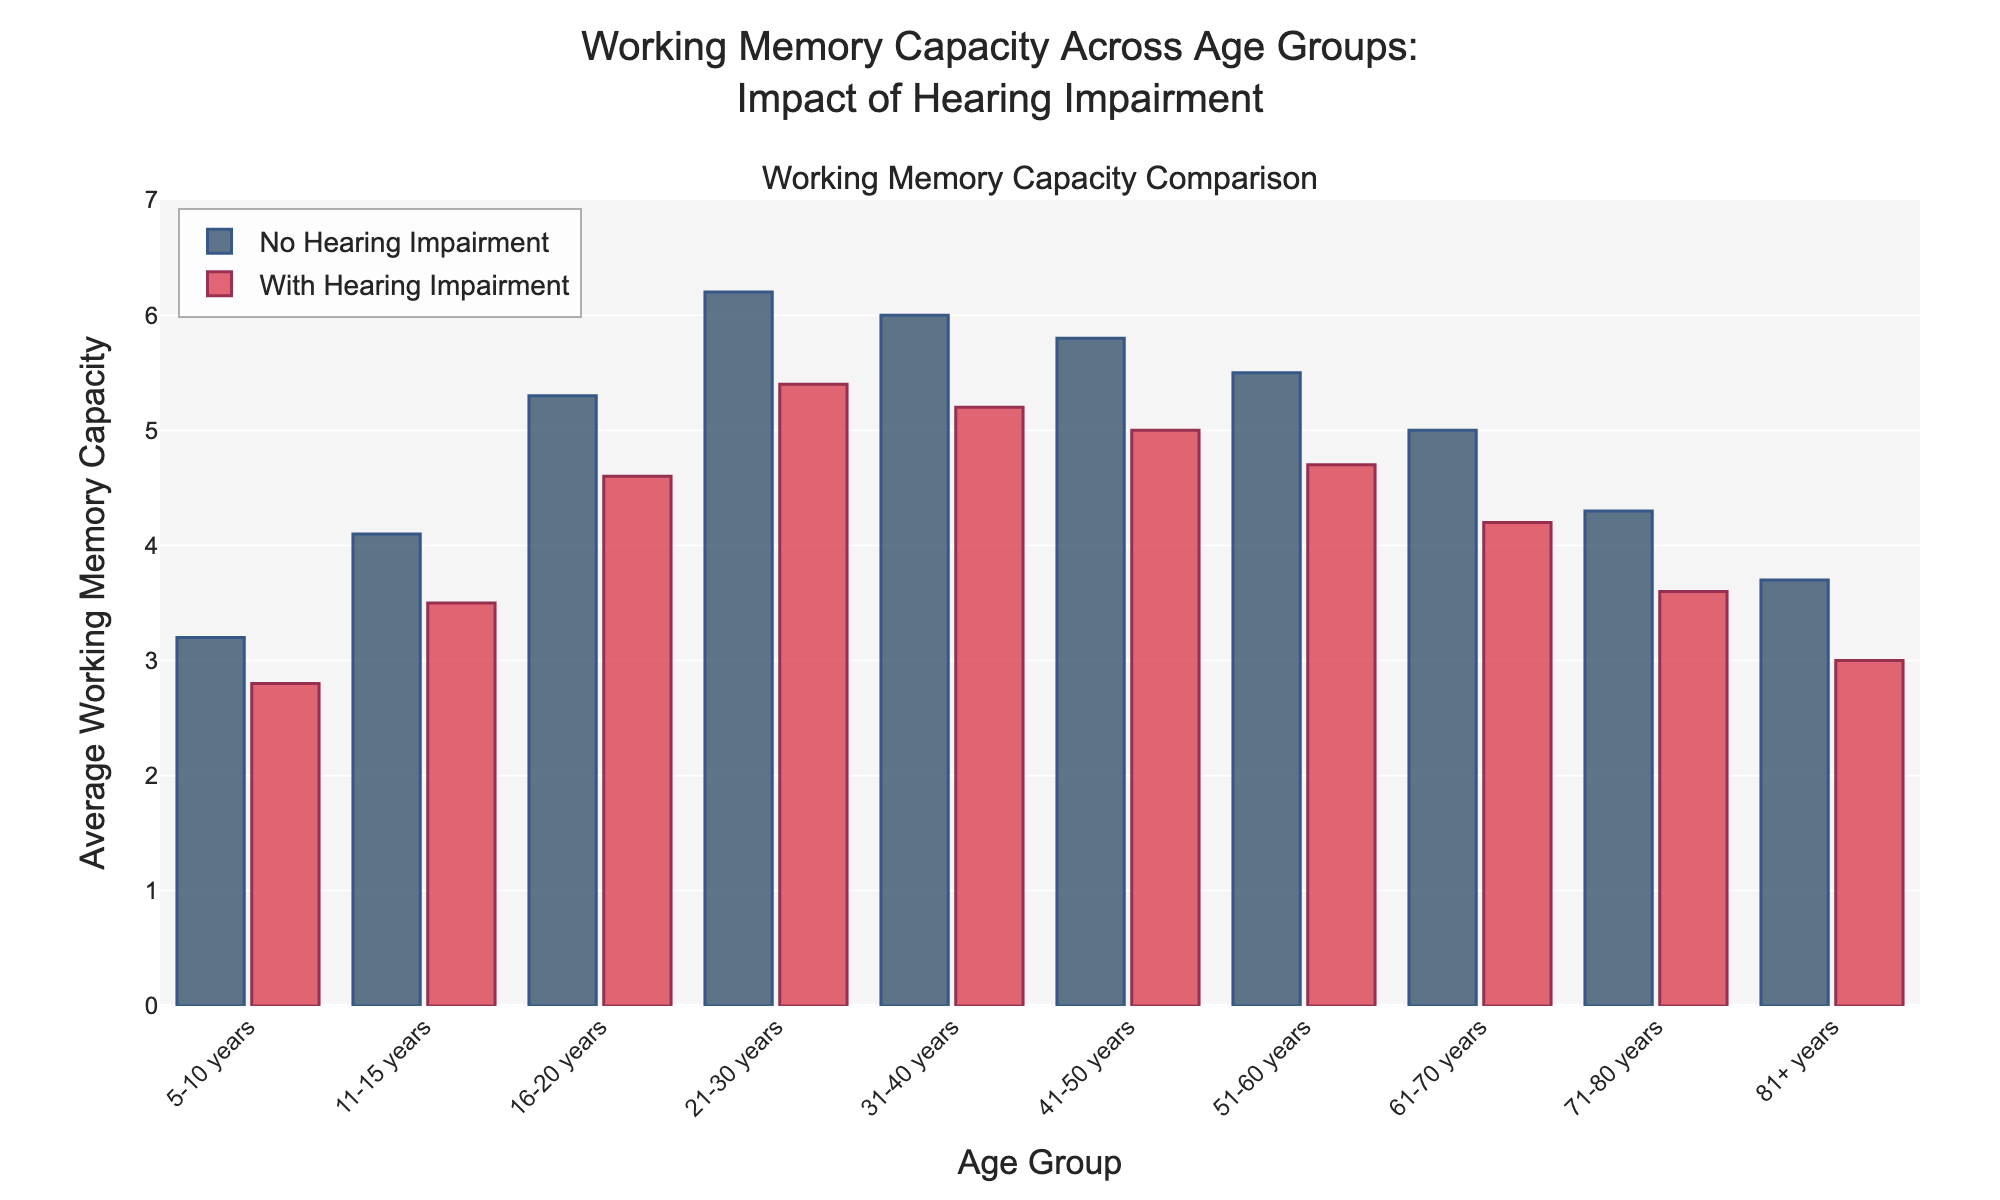What is the difference in average working memory capacity between 16-20 years and 81+ years for individuals without hearing impairments? The average working memory capacity for 16-20 years is 5.3, and for 81+ years, it is 3.7. The difference is calculated as 5.3 - 3.7.
Answer: 1.6 Which age group shows the smallest difference in average working memory capacity between individuals with and without hearing impairments? For each age group, calculate the difference: (0.4 for 5-10 years, 0.6 for 11-15 years, 0.7 for 16-20 years, 0.8 for 21-30 years, 0.8 for 31-40 years, 0.8 for 41-50 years, 0.8 for 51-60 years, 0.8 for 61-70 years, 0.7 for 71-80 years, and 0.7 for 81+ years). The smallest difference is 0.4 in the 5-10 years group.
Answer: 5-10 years At what age group does the working memory capacity peak for individuals without hearing impairments, and what is the value? By visually inspecting the height of the bars for individuals without hearing impairments, the peak occurs in the 21-30 years age group with a value of 6.2.
Answer: 21-30 years, 6.2 Which age group's bar height is the highest for individuals with hearing impairments? By visually comparing the bar heights for individuals with hearing impairments, the highest bar corresponds to the 21-30 years age group.
Answer: 21-30 years How does the average working memory capacity for individuals with hearing impairments in the 41-50 years age group compare to those without impairments in the same age group? For the 41-50 years age group, the average working memory capacity is 5.8 without impairments and 5.0 with impairments. Compare the values directly.
Answer: Less What is the average working memory capacity for individuals with hearing impairments in the 5-10 years and 11-15 years age groups combined? Calculate the average: (2.8 for 5-10 years and 3.5 for 11-15 years). The combined average is (2.8 + 3.5) / 2.
Answer: 3.15 Identify the age group where the difference between the capacities of individuals with and without hearing impairments is greatest. Calculate the difference for each age group: (0.4 for 5-10 years, 0.6 for 11-15 years, 0.7 for 16-20 years, 0.8 for 21-30 years, 0.8 for 31-40 years, 0.8 for 41-50 years, 0.8 for 51-60 years, 0.8 for 61-70 years, 0.7 for 71-80 years, and 0.7 for 81+ years). The greatest difference is 0.8 occurring in multiple age groups.
Answer: 21-30 years, 31-40 years, 41-50 years, 51-60 years, 61-70 years Which group shows a declining trend in average working memory capacity as age increases for both individuals with and without hearing impairments? By visual inspection, observe that both bars for individuals with and without impairments generally decrease in height with increasing age. All age groups observe this pattern.
Answer: All age groups What is the combined average working memory capacity for individuals without hearing impairments across all age groups? Calculate the combined average: (3.2 + 4.1 + 5.3 + 6.2 + 6.0 + 5.8 + 5.5 + 5.0 + 4.3 + 3.7) / 10.
Answer: 4.91 